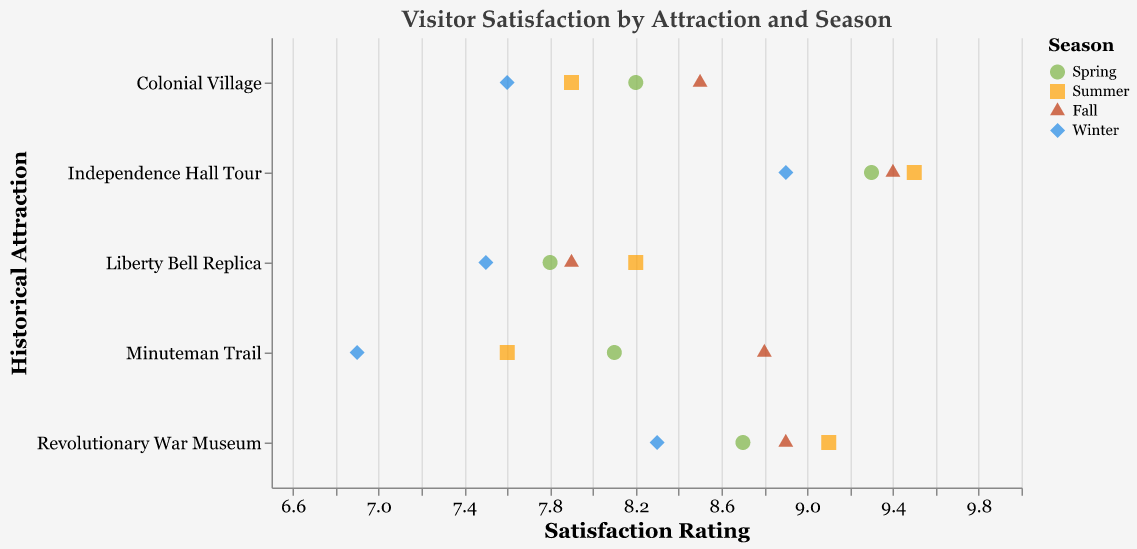What's the highest satisfaction rating for the Independence Hall Tour? To find the highest rating, locate all points representing the Independence Hall Tour, and observe the maximum value. The highest values are 9.5 in Summer.
Answer: 9.5 Which season has the lowest satisfaction for the Minuteman Trail? Identify the points for each season related to the Minuteman Trail and determine the lowest satisfaction score among them. Winter has the lowest rating at 6.9.
Answer: Winter How does the satisfaction rating for the Liberty Bell Replica compare between Spring and Fall? Compare the satisfaction scores for the Liberty Bell Replica for both Spring and Fall from the plot: 7.8 in Spring and 7.9 in Fall. Fall has a slightly higher satisfaction.
Answer: Fall What is the average satisfaction rating for Colonial Village across all seasons? Calculate the mean of satisfaction ratings for Colonial Village across all seasons: (8.2 + 7.9 + 8.5 + 7.6) / 4 = 8.05.
Answer: 8.05 Identify the attraction with the highest average satisfaction rating. Compute the average satisfaction for each attraction across all seasons and find the highest. Independence Hall Tour: (9.3 + 9.5 + 9.4 + 8.9) / 4 = 9.275, which is the highest among all.
Answer: Independence Hall Tour Which season has the highest overall visitor satisfaction across all attractions? To determine this, consider satisfaction ratings for all seasons and identify the one with the most occurrences of high values. Summer often has high values (9.5, 9.1, 8.2), making it the highest.
Answer: Summer How do the satisfaction ratings for the Revolutionary War Museum change across the seasons? Observe the season-wise points for the Revolutionary War Museum and describe the trend. The ratings go from 8.7 in Spring to 9.1 in Summer, 8.9 in Fall, and drop to 8.3 in Winter.
Answer: Increases in Summer, then decreases in Winter Are there any attractions with a satisfaction rating of 7.5? If yes, name them. Identify points with the satisfaction value of 7.5 on the plot and find their corresponding attractions. The Liberty Bell Replica in Winter has a rating of 7.5.
Answer: Liberty Bell Replica (Winter) What is the trend in visitor satisfaction for Independence Hall Tour from Spring to Winter? Check the satisfaction ratings for Independence Hall Tour from Spring to Winter to identify the trend. The scores are 9.3 in Spring, 9.5 in Summer, 9.4 in Fall, and 8.9 in Winter, showing a decreasing trend after Summer.
Answer: Decreasing after Summer 